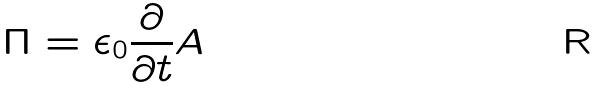<formula> <loc_0><loc_0><loc_500><loc_500>\Pi = \epsilon _ { 0 } \frac { \partial } { \partial t } A</formula> 